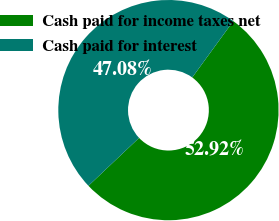Convert chart. <chart><loc_0><loc_0><loc_500><loc_500><pie_chart><fcel>Cash paid for income taxes net<fcel>Cash paid for interest<nl><fcel>52.92%<fcel>47.08%<nl></chart> 